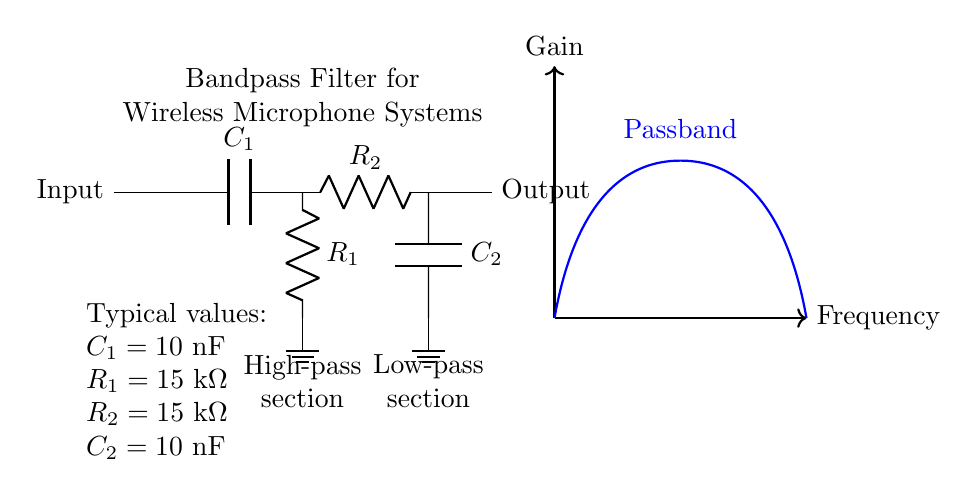What are the components in the high-pass section? The components in the high-pass section are a capacitor C1 and a resistor R1. These are arranged in series, where C1 allows higher frequencies to pass while blocking lower frequencies.
Answer: Capacitor C1 and resistor R1 What is the value of C1 in the circuit? The value of C1 is indicated in the circuit diagram, which states that C1 is 10 nF. This value is important for determining the cutoff frequency in the high-pass filter.
Answer: 10 nF What is the function of the low-pass section? The low-pass section of the filter, which consists of a resistor R2 and a capacitor C2, allows low-frequency signals to pass while attenuating high-frequency signals, thereby creating a complete bandpass filter.
Answer: To allow low frequencies and block high frequencies What is the purpose of a bandpass filter in wireless microphone systems? The function of a bandpass filter in wireless microphone systems is to allow a specific range of frequencies to pass through while attenuating frequencies outside this range, thus reducing interference and ensuring clear audio transmission.
Answer: Reduce interference How do R1 and R2 interact in this circuit? R1 is part of the high-pass section, while R2 is part of the low-pass section. Their values determine the cutoff frequencies for the respective sections and together create the overall bandwidth of the filter. This interaction sets the frequency range that will be passed through the system.
Answer: Determine the bandwidth What is the characteristic response of the bandpass filter? The characteristic response of the bandpass filter, as shown in the diagram, is a peak in gain within a specific frequency range (the passband) and drops off gain at frequencies outside this range, represented by the curve that rises and falls.
Answer: Gain peak in the passband 